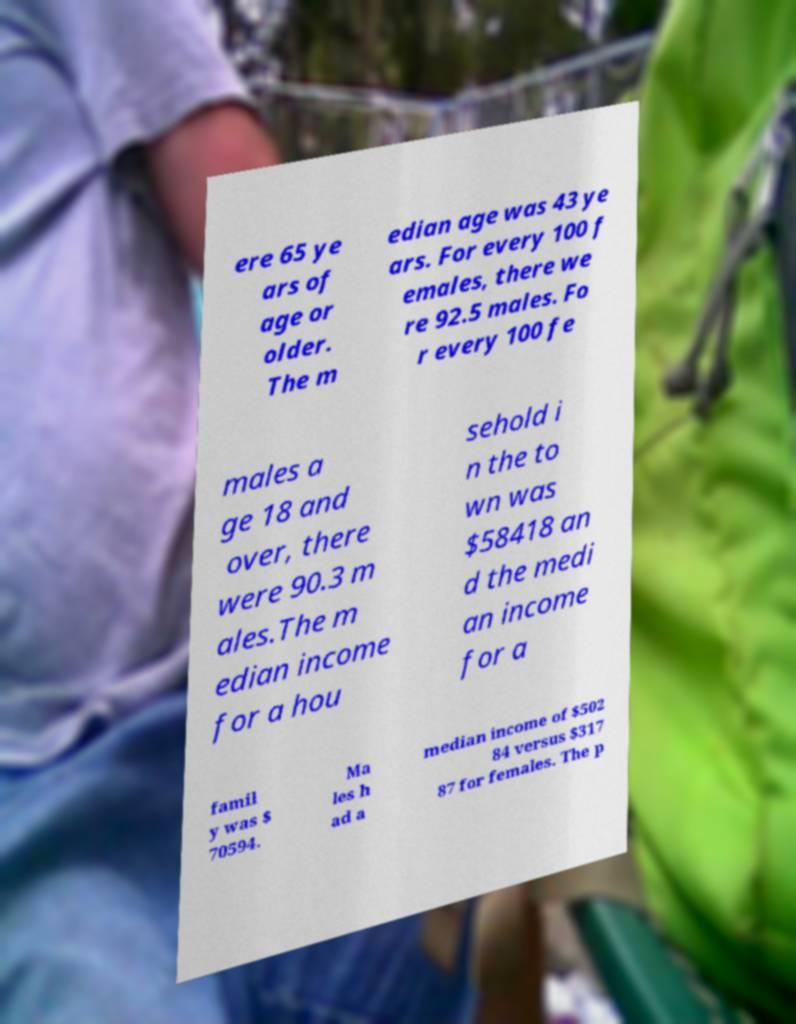What messages or text are displayed in this image? I need them in a readable, typed format. ere 65 ye ars of age or older. The m edian age was 43 ye ars. For every 100 f emales, there we re 92.5 males. Fo r every 100 fe males a ge 18 and over, there were 90.3 m ales.The m edian income for a hou sehold i n the to wn was $58418 an d the medi an income for a famil y was $ 70594. Ma les h ad a median income of $502 84 versus $317 87 for females. The p 